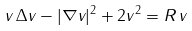<formula> <loc_0><loc_0><loc_500><loc_500>v \, \Delta v - | \nabla v | ^ { 2 } + 2 v ^ { 2 } = R \, v</formula> 